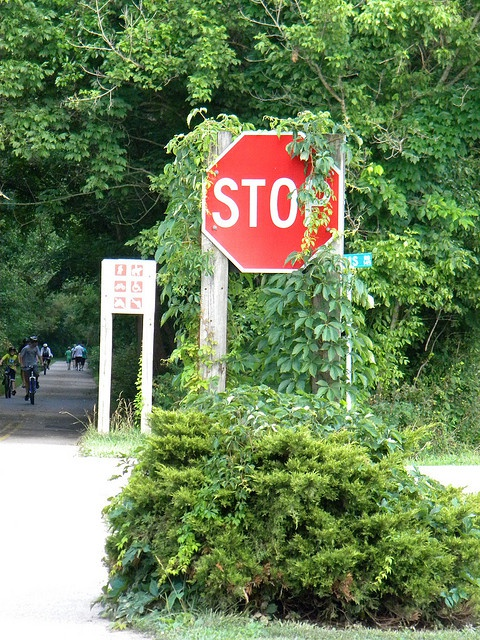Describe the objects in this image and their specific colors. I can see stop sign in olive, salmon, white, and red tones, people in olive, black, gray, blue, and navy tones, people in olive, black, gray, and darkgreen tones, bicycle in olive, black, gray, darkgreen, and navy tones, and bicycle in olive, black, navy, purple, and darkblue tones in this image. 